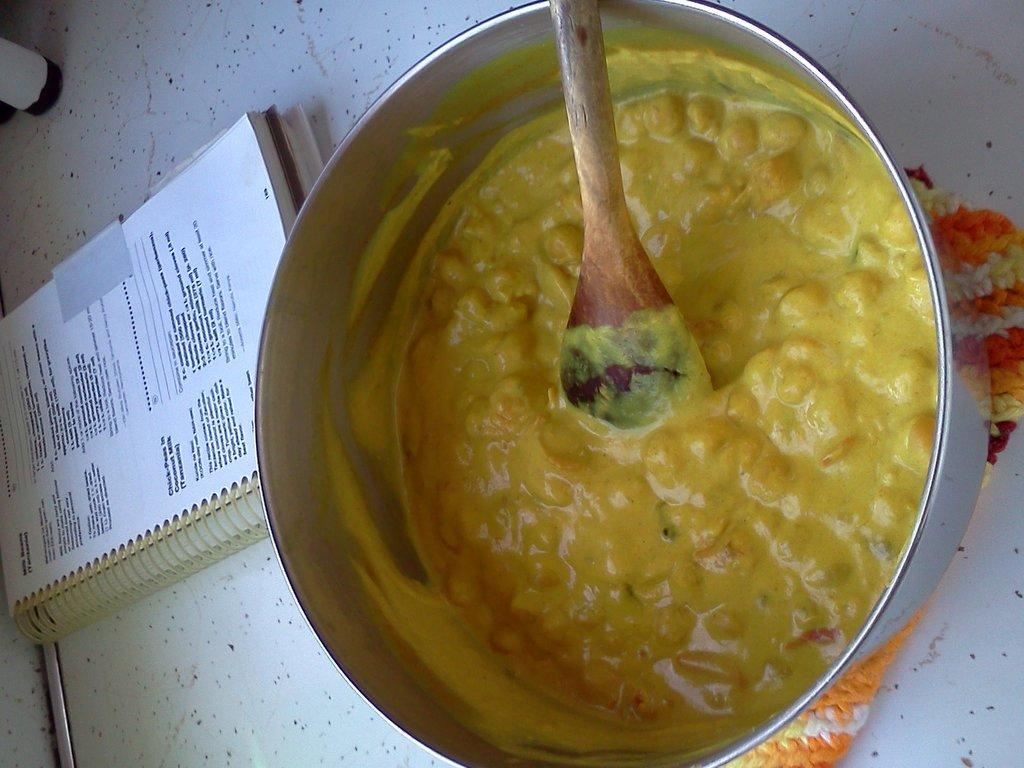What type of food item can be seen in the image? There is a food item in the image, but its specific type is not mentioned in the facts. What utensil is present in the image? There is a wooden spoon in the image. Where is the wooden spoon located? The wooden spoon is in a steel bowl. What other object can be seen in the image? There is a book in the image. What is the color of the surface on which the objects are placed? The objects are on a white color surface. What type of detail can be seen on the toad in the image? There is no toad present in the image, so there are no details to describe. What type of frame surrounds the image? The facts provided do not mention a frame surrounding the image. 